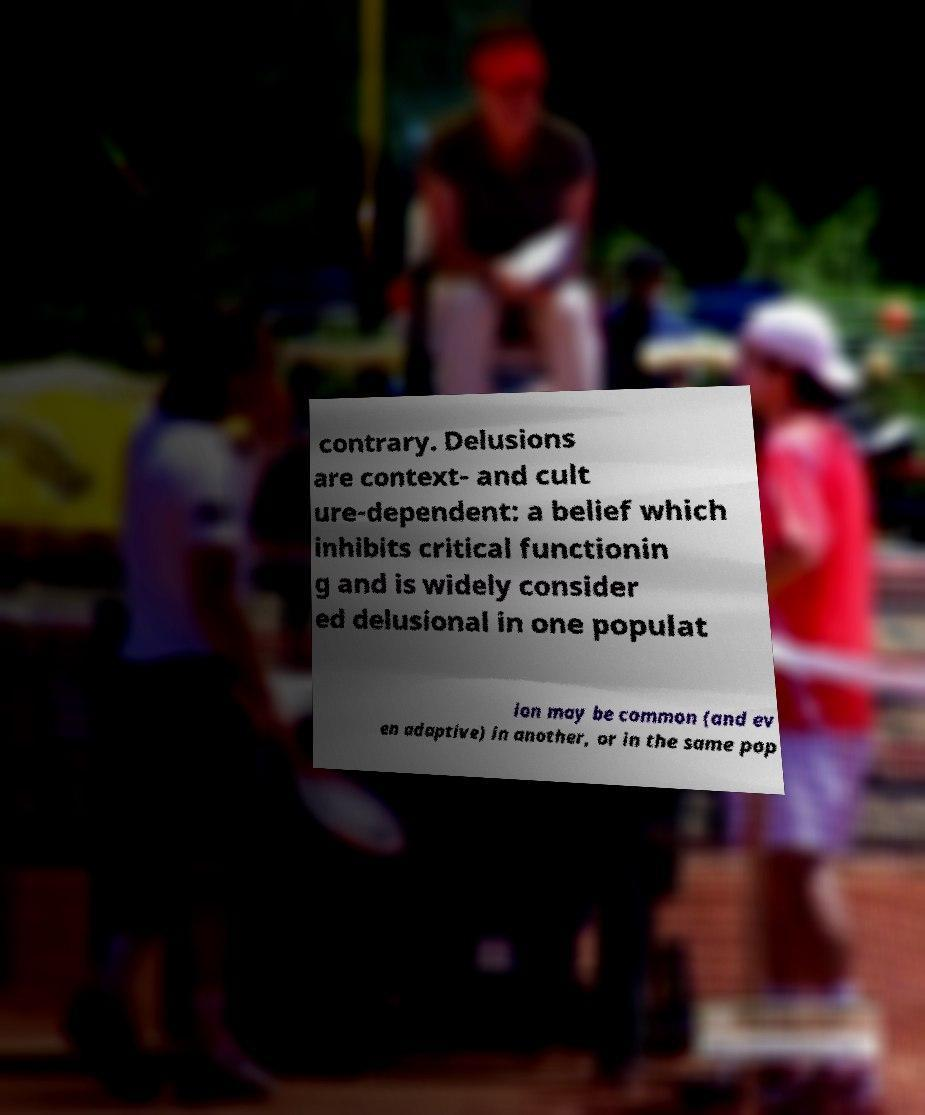Could you extract and type out the text from this image? contrary. Delusions are context- and cult ure-dependent: a belief which inhibits critical functionin g and is widely consider ed delusional in one populat ion may be common (and ev en adaptive) in another, or in the same pop 